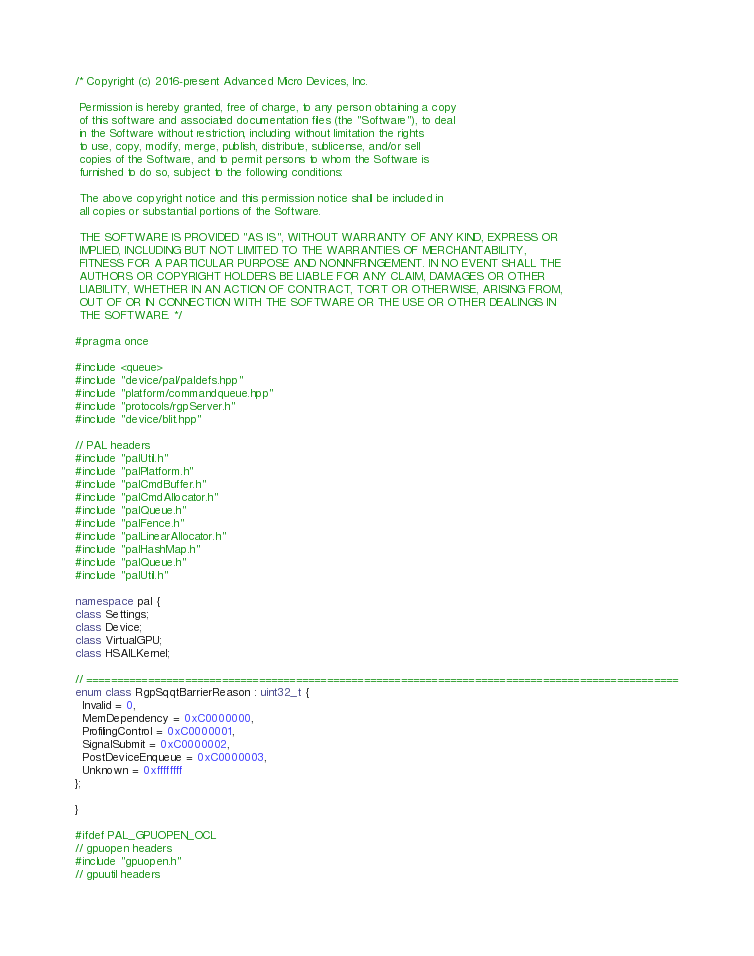<code> <loc_0><loc_0><loc_500><loc_500><_C++_>/* Copyright (c) 2016-present Advanced Micro Devices, Inc.

 Permission is hereby granted, free of charge, to any person obtaining a copy
 of this software and associated documentation files (the "Software"), to deal
 in the Software without restriction, including without limitation the rights
 to use, copy, modify, merge, publish, distribute, sublicense, and/or sell
 copies of the Software, and to permit persons to whom the Software is
 furnished to do so, subject to the following conditions:

 The above copyright notice and this permission notice shall be included in
 all copies or substantial portions of the Software.

 THE SOFTWARE IS PROVIDED "AS IS", WITHOUT WARRANTY OF ANY KIND, EXPRESS OR
 IMPLIED, INCLUDING BUT NOT LIMITED TO THE WARRANTIES OF MERCHANTABILITY,
 FITNESS FOR A PARTICULAR PURPOSE AND NONINFRINGEMENT. IN NO EVENT SHALL THE
 AUTHORS OR COPYRIGHT HOLDERS BE LIABLE FOR ANY CLAIM, DAMAGES OR OTHER
 LIABILITY, WHETHER IN AN ACTION OF CONTRACT, TORT OR OTHERWISE, ARISING FROM,
 OUT OF OR IN CONNECTION WITH THE SOFTWARE OR THE USE OR OTHER DEALINGS IN
 THE SOFTWARE. */

#pragma once

#include <queue>
#include "device/pal/paldefs.hpp"
#include "platform/commandqueue.hpp"
#include "protocols/rgpServer.h"
#include "device/blit.hpp"

// PAL headers
#include "palUtil.h"
#include "palPlatform.h"
#include "palCmdBuffer.h"
#include "palCmdAllocator.h"
#include "palQueue.h"
#include "palFence.h"
#include "palLinearAllocator.h"
#include "palHashMap.h"
#include "palQueue.h"
#include "palUtil.h"

namespace pal {
class Settings;
class Device;
class VirtualGPU;
class HSAILKernel;

// ================================================================================================
enum class RgpSqqtBarrierReason : uint32_t {
  Invalid = 0,
  MemDependency = 0xC0000000,
  ProfilingControl = 0xC0000001,
  SignalSubmit = 0xC0000002,
  PostDeviceEnqueue = 0xC0000003,
  Unknown = 0xffffffff
};

}

#ifdef PAL_GPUOPEN_OCL
// gpuopen headers
#include "gpuopen.h"
// gpuutil headers</code> 